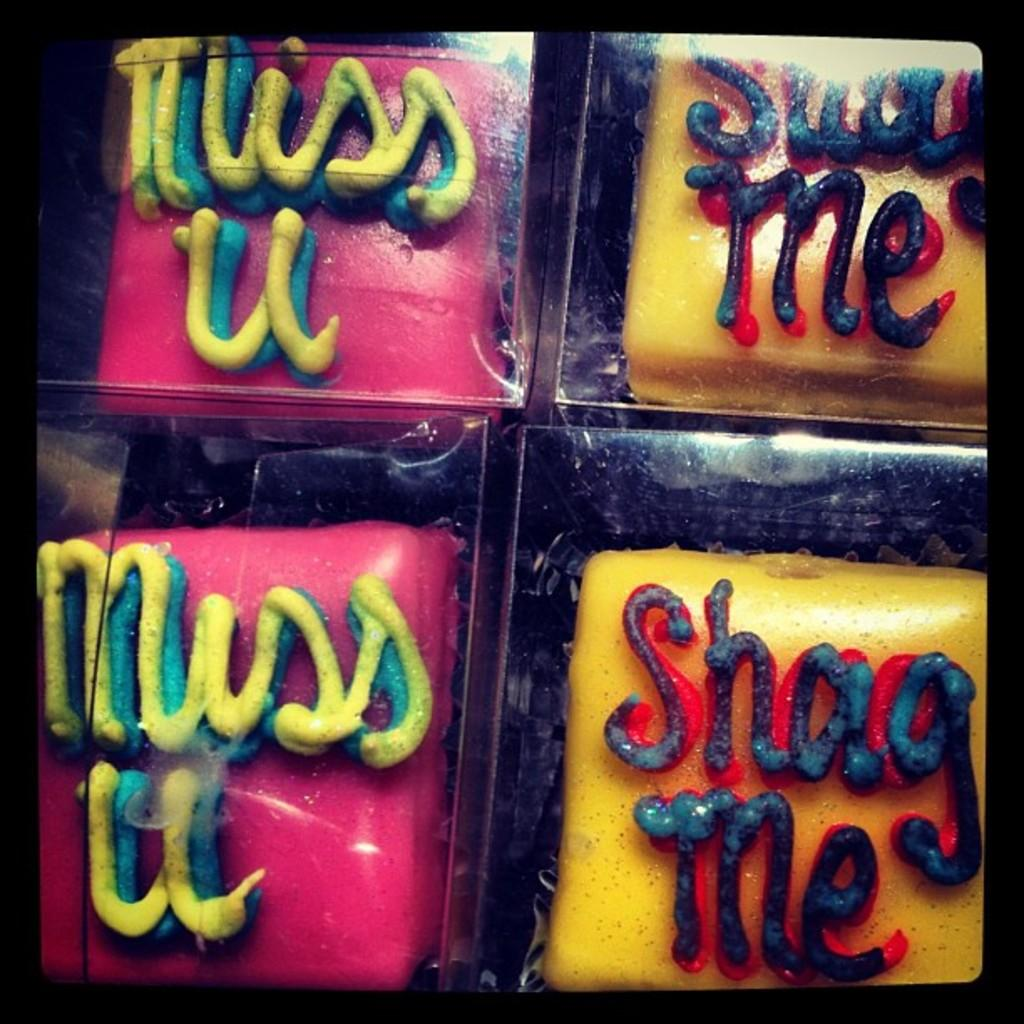What colors are the boards in the image? The boards in the image are pink and yellow. What is written or depicted on the boards? There is text on the boards. What type of object is the image likely to be? The image appears to be a photo frame. Can you see any yams or quinces in the image? No, there are no yams or quinces present in the image. Is there a tiger visible in the image? No, there is no tiger visible in the image. 